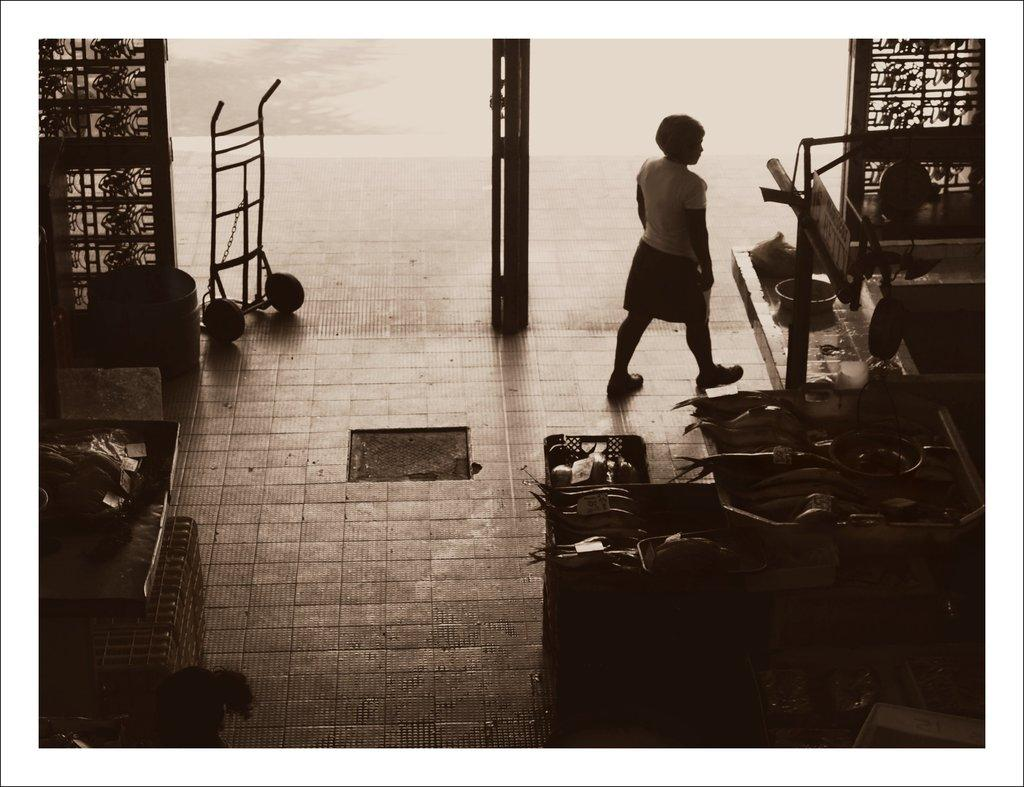Who or what is present in the image? There is a person in the image. What is the person doing in the image? The person is walking. What type of furniture can be seen in the image? There are tables and chairs in the image. What type of bulb is being used by the person in the image? There is no bulb present in the image; it only features a person walking and furniture. 